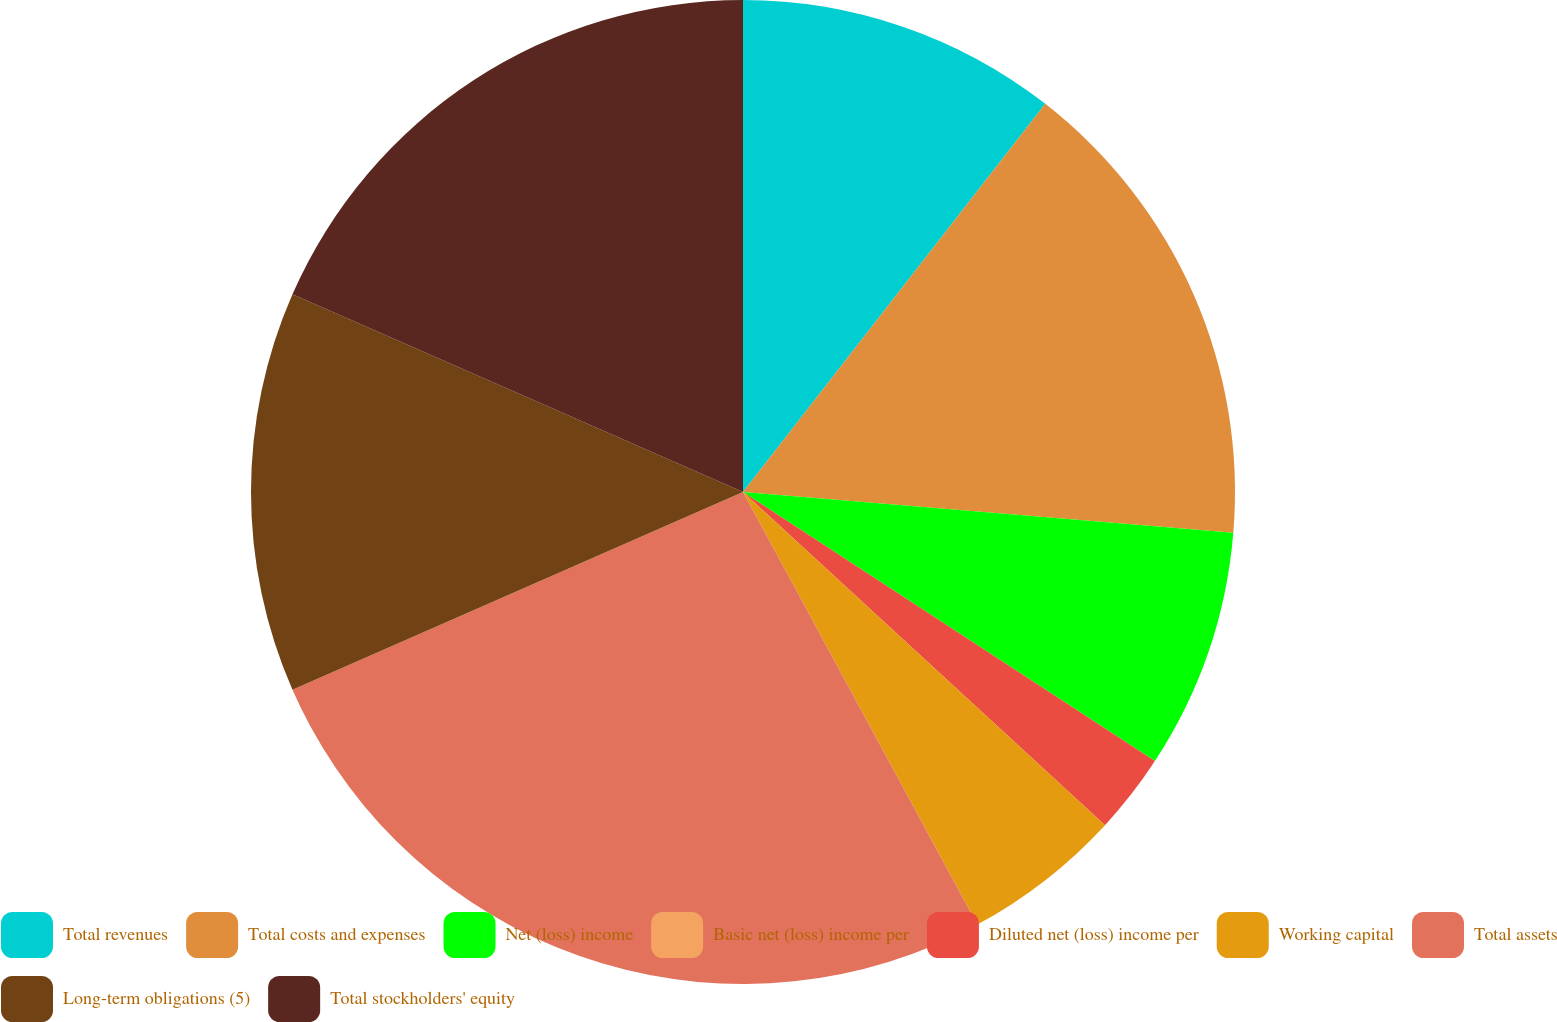<chart> <loc_0><loc_0><loc_500><loc_500><pie_chart><fcel>Total revenues<fcel>Total costs and expenses<fcel>Net (loss) income<fcel>Basic net (loss) income per<fcel>Diluted net (loss) income per<fcel>Working capital<fcel>Total assets<fcel>Long-term obligations (5)<fcel>Total stockholders' equity<nl><fcel>10.53%<fcel>15.79%<fcel>7.89%<fcel>0.0%<fcel>2.63%<fcel>5.26%<fcel>26.32%<fcel>13.16%<fcel>18.42%<nl></chart> 